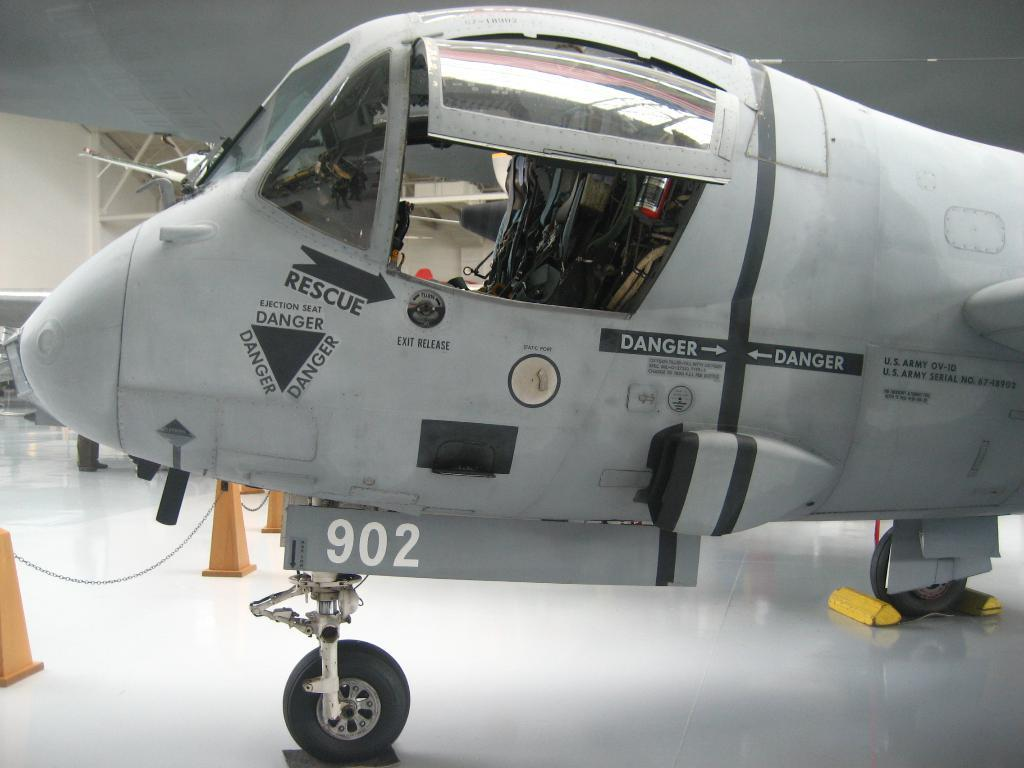What is the main subject of the image? There is a plane in the image. What is located near the plane? There is a barrier in the image. What else can be seen on the floor in the image? There are other objects on the floor in the image. What is visible in the background of the image? There is a wall and rods in the background of the image. What type of yam is being harvested in the alley behind the plane in the image? There is no yam or alley present in the image; it features a plane, a barrier, and other objects on the floor. Can you tell me how many boats are docked at the harbor in the image? There is no harbor or boats present in the image; it features a plane, a barrier, and other objects on the floor. 